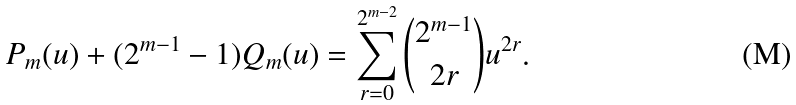<formula> <loc_0><loc_0><loc_500><loc_500>P _ { m } ( u ) + ( 2 ^ { m - 1 } - 1 ) Q _ { m } ( u ) = \sum _ { r = 0 } ^ { 2 ^ { m - 2 } } \binom { 2 ^ { m - 1 } } { 2 r } u ^ { 2 r } .</formula> 